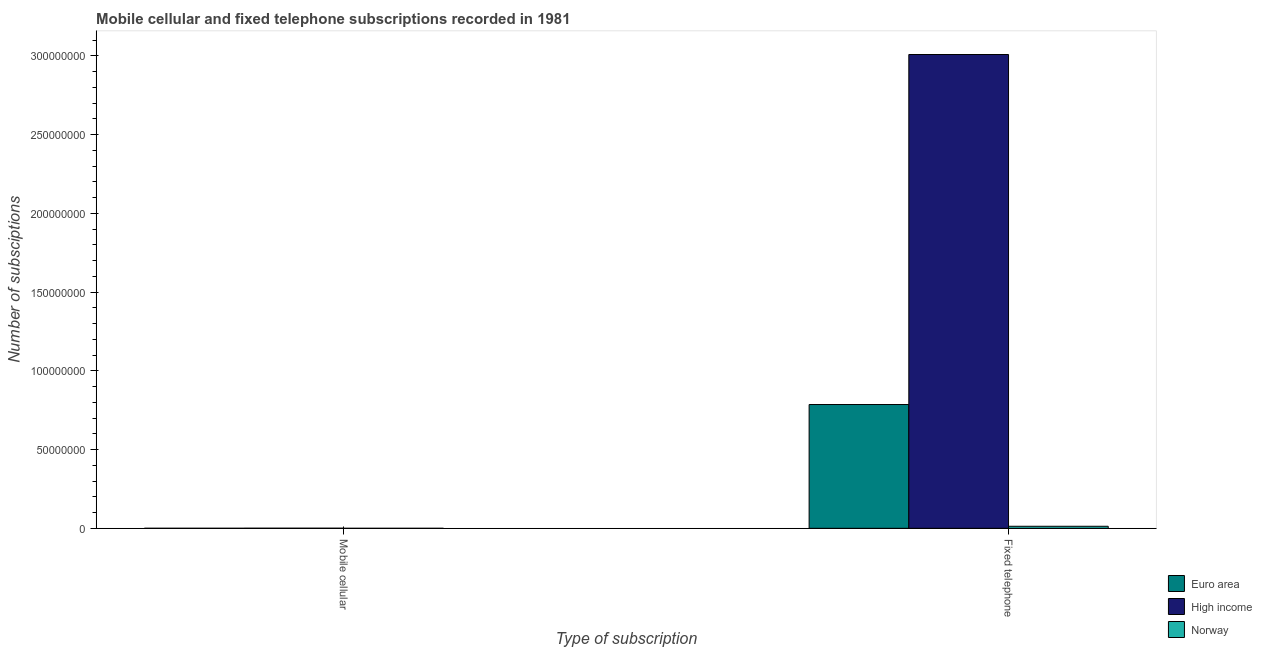How many different coloured bars are there?
Provide a short and direct response. 3. How many groups of bars are there?
Make the answer very short. 2. Are the number of bars on each tick of the X-axis equal?
Provide a succinct answer. Yes. How many bars are there on the 2nd tick from the left?
Provide a short and direct response. 3. What is the label of the 1st group of bars from the left?
Your response must be concise. Mobile cellular. What is the number of fixed telephone subscriptions in Euro area?
Offer a terse response. 7.86e+07. Across all countries, what is the maximum number of fixed telephone subscriptions?
Provide a succinct answer. 3.01e+08. Across all countries, what is the minimum number of fixed telephone subscriptions?
Keep it short and to the point. 1.30e+06. In which country was the number of mobile cellular subscriptions maximum?
Your answer should be compact. High income. In which country was the number of fixed telephone subscriptions minimum?
Your answer should be very brief. Norway. What is the total number of fixed telephone subscriptions in the graph?
Keep it short and to the point. 3.81e+08. What is the difference between the number of fixed telephone subscriptions in High income and that in Euro area?
Offer a terse response. 2.22e+08. What is the difference between the number of mobile cellular subscriptions in Euro area and the number of fixed telephone subscriptions in Norway?
Offer a very short reply. -1.27e+06. What is the average number of fixed telephone subscriptions per country?
Your answer should be compact. 1.27e+08. What is the difference between the number of fixed telephone subscriptions and number of mobile cellular subscriptions in Euro area?
Your answer should be compact. 7.86e+07. What is the ratio of the number of mobile cellular subscriptions in High income to that in Norway?
Keep it short and to the point. 38.07. What does the 3rd bar from the left in Fixed telephone represents?
Offer a terse response. Norway. What does the 3rd bar from the right in Mobile cellular represents?
Your answer should be very brief. Euro area. How many bars are there?
Keep it short and to the point. 6. Are all the bars in the graph horizontal?
Give a very brief answer. No. How many countries are there in the graph?
Provide a short and direct response. 3. What is the difference between two consecutive major ticks on the Y-axis?
Offer a terse response. 5.00e+07. Does the graph contain any zero values?
Ensure brevity in your answer.  No. Does the graph contain grids?
Your answer should be very brief. No. What is the title of the graph?
Make the answer very short. Mobile cellular and fixed telephone subscriptions recorded in 1981. Does "Sierra Leone" appear as one of the legend labels in the graph?
Ensure brevity in your answer.  No. What is the label or title of the X-axis?
Give a very brief answer. Type of subscription. What is the label or title of the Y-axis?
Offer a very short reply. Number of subsciptions. What is the Number of subsciptions of Euro area in Mobile cellular?
Your response must be concise. 2.83e+04. What is the Number of subsciptions of High income in Mobile cellular?
Your answer should be compact. 6.36e+04. What is the Number of subsciptions in Norway in Mobile cellular?
Give a very brief answer. 1670. What is the Number of subsciptions in Euro area in Fixed telephone?
Give a very brief answer. 7.86e+07. What is the Number of subsciptions in High income in Fixed telephone?
Provide a succinct answer. 3.01e+08. What is the Number of subsciptions of Norway in Fixed telephone?
Your answer should be compact. 1.30e+06. Across all Type of subscription, what is the maximum Number of subsciptions in Euro area?
Your answer should be very brief. 7.86e+07. Across all Type of subscription, what is the maximum Number of subsciptions of High income?
Your answer should be very brief. 3.01e+08. Across all Type of subscription, what is the maximum Number of subsciptions in Norway?
Your answer should be compact. 1.30e+06. Across all Type of subscription, what is the minimum Number of subsciptions in Euro area?
Keep it short and to the point. 2.83e+04. Across all Type of subscription, what is the minimum Number of subsciptions in High income?
Provide a short and direct response. 6.36e+04. Across all Type of subscription, what is the minimum Number of subsciptions of Norway?
Provide a succinct answer. 1670. What is the total Number of subsciptions in Euro area in the graph?
Your answer should be very brief. 7.86e+07. What is the total Number of subsciptions of High income in the graph?
Ensure brevity in your answer.  3.01e+08. What is the total Number of subsciptions in Norway in the graph?
Ensure brevity in your answer.  1.30e+06. What is the difference between the Number of subsciptions of Euro area in Mobile cellular and that in Fixed telephone?
Ensure brevity in your answer.  -7.86e+07. What is the difference between the Number of subsciptions in High income in Mobile cellular and that in Fixed telephone?
Offer a very short reply. -3.01e+08. What is the difference between the Number of subsciptions in Norway in Mobile cellular and that in Fixed telephone?
Give a very brief answer. -1.30e+06. What is the difference between the Number of subsciptions of Euro area in Mobile cellular and the Number of subsciptions of High income in Fixed telephone?
Give a very brief answer. -3.01e+08. What is the difference between the Number of subsciptions of Euro area in Mobile cellular and the Number of subsciptions of Norway in Fixed telephone?
Offer a very short reply. -1.27e+06. What is the difference between the Number of subsciptions of High income in Mobile cellular and the Number of subsciptions of Norway in Fixed telephone?
Keep it short and to the point. -1.23e+06. What is the average Number of subsciptions in Euro area per Type of subscription?
Offer a terse response. 3.93e+07. What is the average Number of subsciptions in High income per Type of subscription?
Give a very brief answer. 1.50e+08. What is the average Number of subsciptions of Norway per Type of subscription?
Keep it short and to the point. 6.50e+05. What is the difference between the Number of subsciptions in Euro area and Number of subsciptions in High income in Mobile cellular?
Make the answer very short. -3.53e+04. What is the difference between the Number of subsciptions in Euro area and Number of subsciptions in Norway in Mobile cellular?
Your answer should be very brief. 2.66e+04. What is the difference between the Number of subsciptions of High income and Number of subsciptions of Norway in Mobile cellular?
Give a very brief answer. 6.19e+04. What is the difference between the Number of subsciptions in Euro area and Number of subsciptions in High income in Fixed telephone?
Your answer should be very brief. -2.22e+08. What is the difference between the Number of subsciptions in Euro area and Number of subsciptions in Norway in Fixed telephone?
Your response must be concise. 7.73e+07. What is the difference between the Number of subsciptions in High income and Number of subsciptions in Norway in Fixed telephone?
Offer a terse response. 3.00e+08. What is the ratio of the Number of subsciptions of Euro area in Mobile cellular to that in Fixed telephone?
Offer a terse response. 0. What is the ratio of the Number of subsciptions in High income in Mobile cellular to that in Fixed telephone?
Offer a very short reply. 0. What is the ratio of the Number of subsciptions in Norway in Mobile cellular to that in Fixed telephone?
Your answer should be very brief. 0. What is the difference between the highest and the second highest Number of subsciptions of Euro area?
Provide a short and direct response. 7.86e+07. What is the difference between the highest and the second highest Number of subsciptions in High income?
Give a very brief answer. 3.01e+08. What is the difference between the highest and the second highest Number of subsciptions of Norway?
Your answer should be very brief. 1.30e+06. What is the difference between the highest and the lowest Number of subsciptions of Euro area?
Ensure brevity in your answer.  7.86e+07. What is the difference between the highest and the lowest Number of subsciptions in High income?
Your response must be concise. 3.01e+08. What is the difference between the highest and the lowest Number of subsciptions of Norway?
Give a very brief answer. 1.30e+06. 